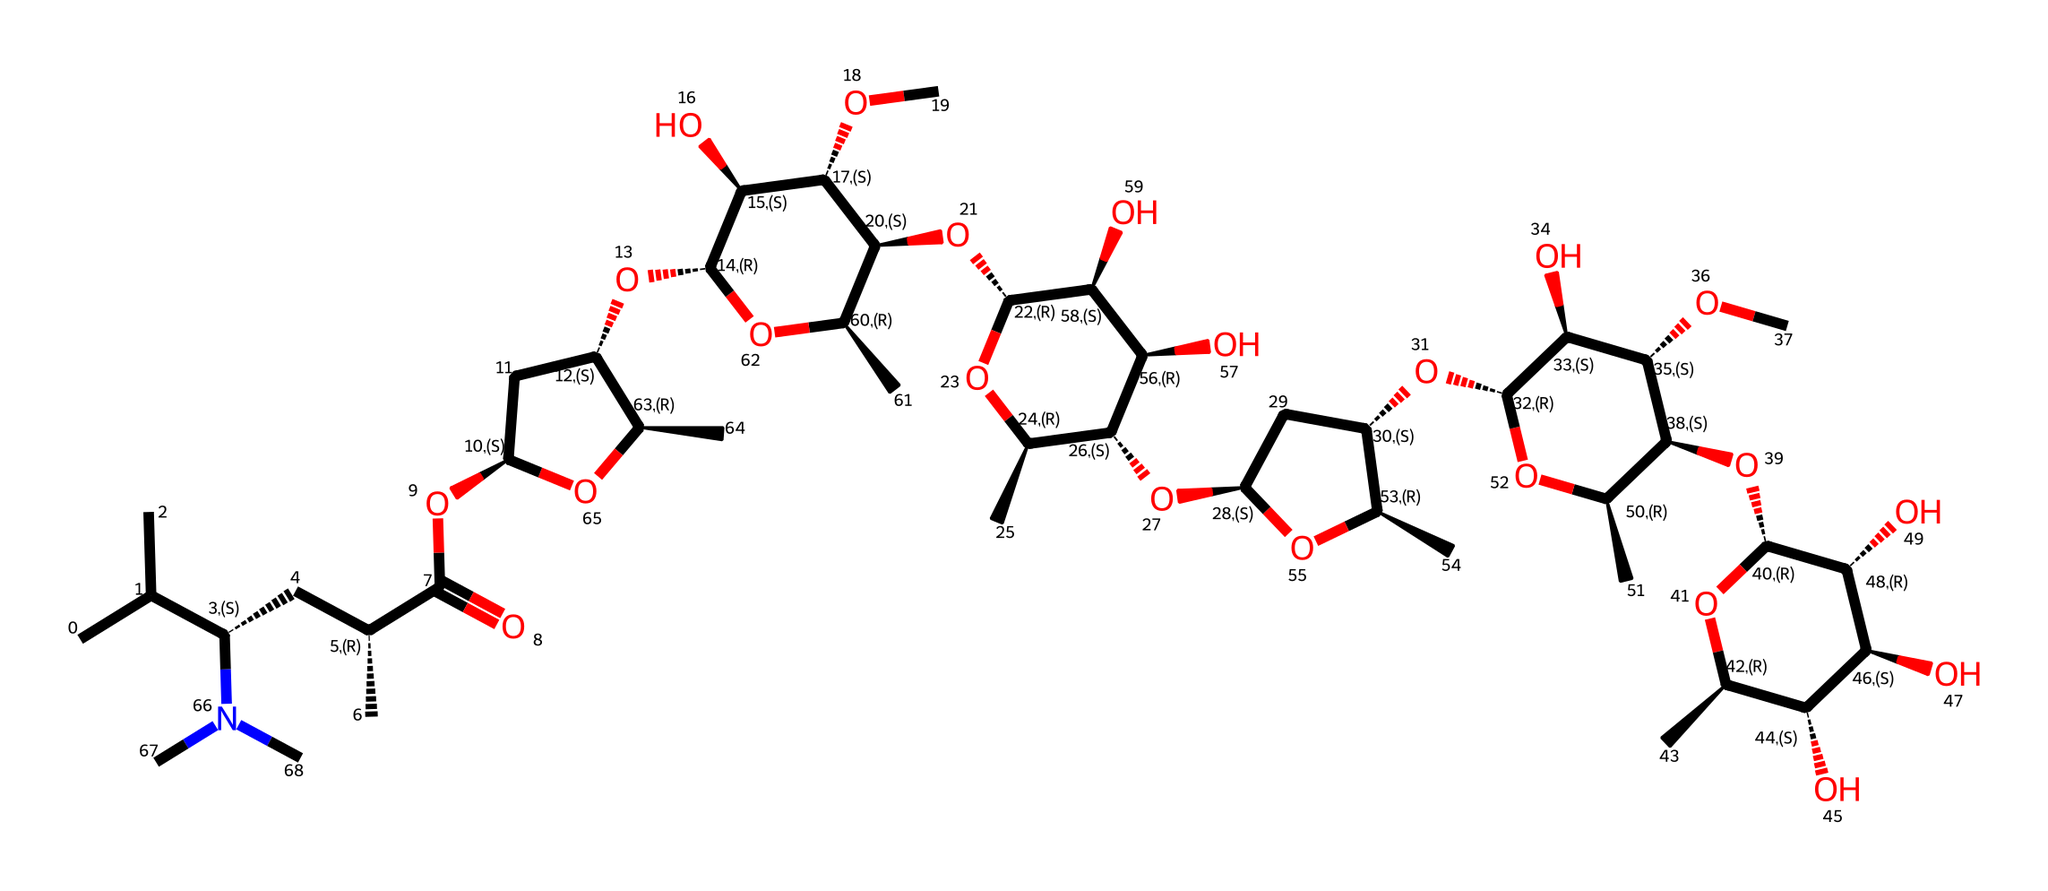What is the primary functional group present in ivermectin? The structure contains a carboxylic acid functional group, as indicated by the presence of the –C(=O)O– moiety within the molecule.
Answer: carboxylic acid How many chiral centers are in ivermectin? By analyzing the structure, there are three distinct carbon atoms that are bonded to four different substituents, indicating the presence of three chiral centers.
Answer: three What does the presence of the nitrogen atom in ivermectin suggest about its medicinal properties? The nitrogen atom usually indicates the potential for forming hydrogen bonds and participating in interactions with biological molecules, enhancing its medicinal activity.
Answer: hydrogen bonds What is the molecular formula of ivermectin? By counting the atoms of carbon, hydrogen, nitrogen, and oxygen in the structure, it can be deduced that the molecular formula is C49H81N2O14.
Answer: C49H81N2O14 What type of compound is ivermectin categorized as? Ivermectin qualifies as a macrocyclic lactone based on its large ring structure fused with ester functional groups, typical of this compound class.
Answer: macrocyclic lactone 